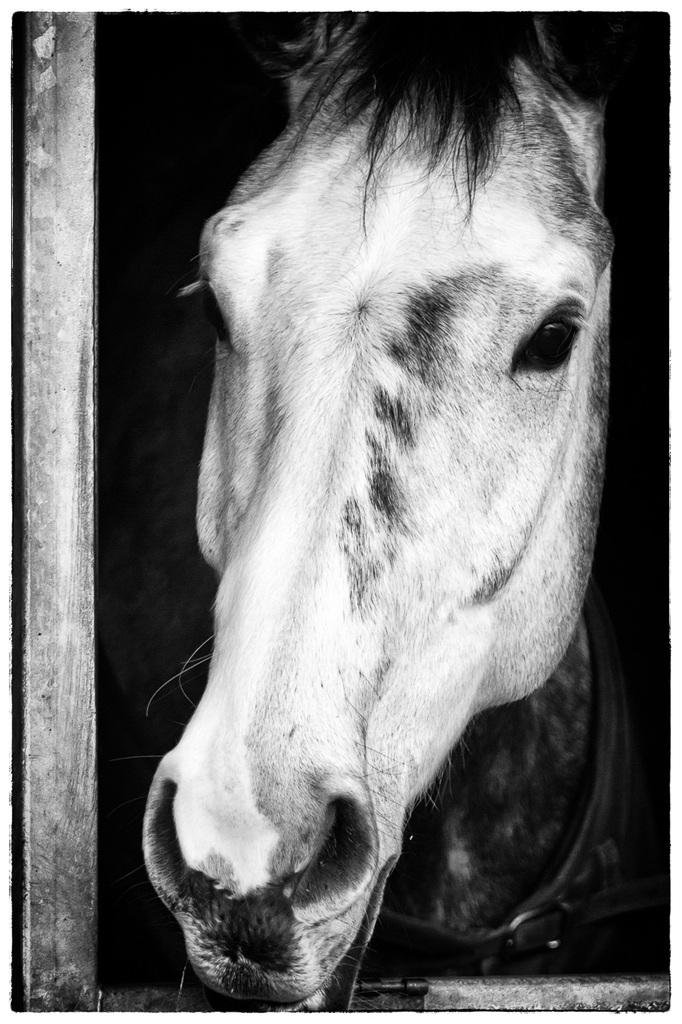What type of animal is present in the image? There is a horse in the image. What structure is visible in the image? There is a wooden stable in the image. What type of country is depicted in the image? The image does not depict a country; it features a horse and a wooden stable. What news can be gathered from the image? The image does not convey any news; it is a static image of a horse and a wooden stable. 